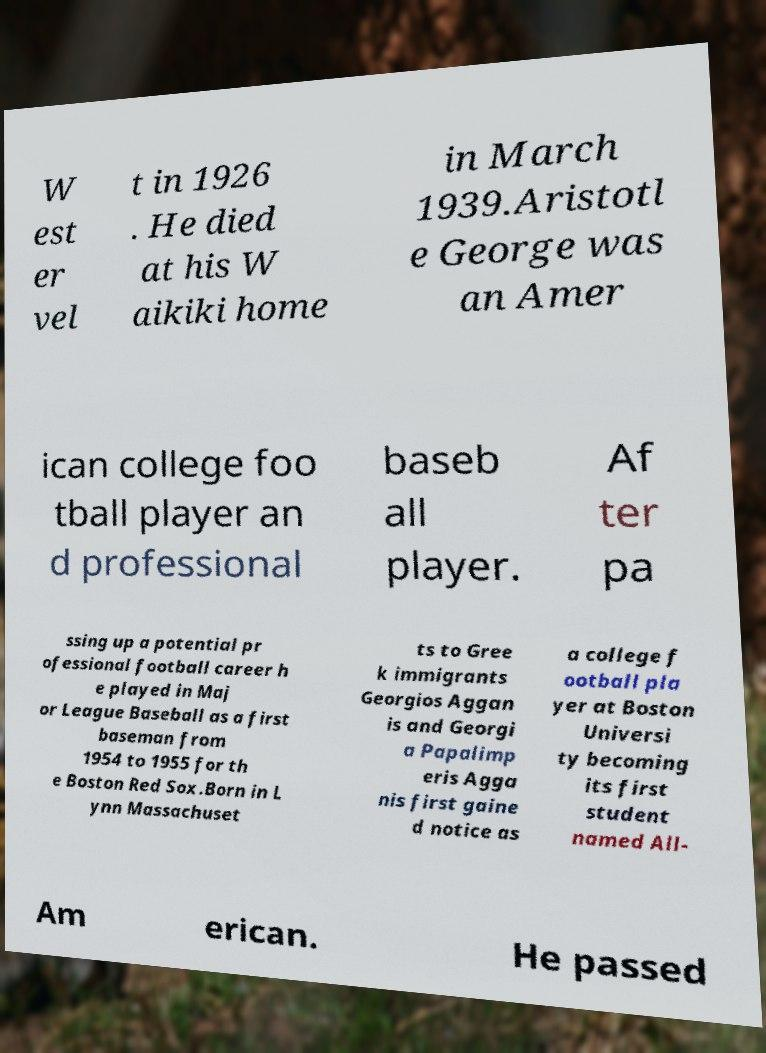Please identify and transcribe the text found in this image. W est er vel t in 1926 . He died at his W aikiki home in March 1939.Aristotl e George was an Amer ican college foo tball player an d professional baseb all player. Af ter pa ssing up a potential pr ofessional football career h e played in Maj or League Baseball as a first baseman from 1954 to 1955 for th e Boston Red Sox.Born in L ynn Massachuset ts to Gree k immigrants Georgios Aggan is and Georgi a Papalimp eris Agga nis first gaine d notice as a college f ootball pla yer at Boston Universi ty becoming its first student named All- Am erican. He passed 